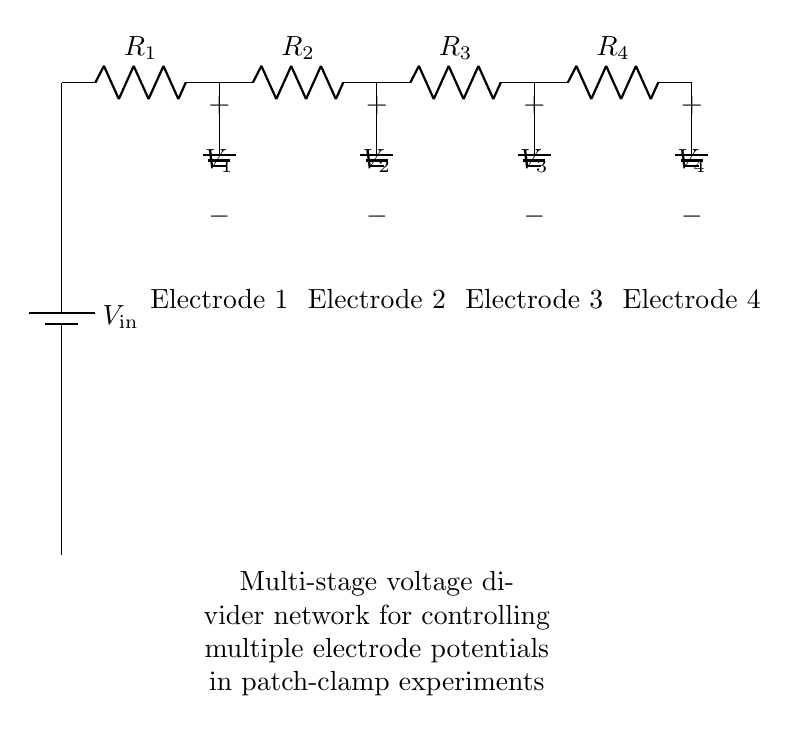What is the input voltage in the circuit? The input voltage is indicated by the symbol V_in at the battery component in the circuit diagram, which represents the voltage supply for the voltage divider.
Answer: V_in How many resistors are used in this voltage divider? The circuit diagram shows four resistors, labeled R_1, R_2, R_3, and R_4, connected in series to form the voltage divider.
Answer: Four What are the names of the electrodes connected to each voltage output? The electrodes connected to the outputs are labeled as Electrode 1, Electrode 2, Electrode 3, and Electrode 4, corresponding to the nodes where voltages V_1, V_2, V_3, and V_4 are measured.
Answer: Electrode 1, Electrode 2, Electrode 3, Electrode 4 What happens to the voltage at the output nodes as you progress through the resistors? In a voltage divider, as you progress through the resistors, the voltage at the output nodes decreases proportionally to the resistance values, leading to reduced potential differences at each node.
Answer: Decreases If R_1, R_2, R_3, and R_4 have equal resistance values, what would be the voltage across each electrode? When all resistors have equal resistance, the input voltage is equally divided among the four output nodes, meaning each output voltage V_n will be one-fourth of V_in.
Answer: V_in / 4 What is the function of the ground connections in the circuit? The ground connections serve as a reference point for the voltage measurements at the output nodes and complete the circuit path, allowing current to flow back to the source.
Answer: Reference point Why is this configuration suitable for patch-clamp experiments? This multi-stage voltage divider allows precise control of multiple electrode potentials, which is crucial for accurately measuring cellular electrophysiological properties in patch-clamp experiments.
Answer: Control of electrode potentials 